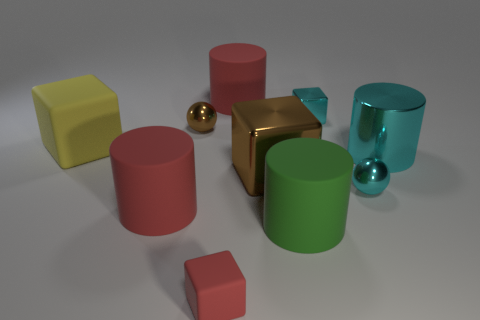Subtract all blue cubes. Subtract all red cylinders. How many cubes are left? 4 Subtract all balls. How many objects are left? 8 Subtract all tiny purple metal cylinders. Subtract all green cylinders. How many objects are left? 9 Add 4 yellow matte blocks. How many yellow matte blocks are left? 5 Add 4 cyan shiny things. How many cyan shiny things exist? 7 Subtract 0 purple balls. How many objects are left? 10 